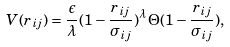Convert formula to latex. <formula><loc_0><loc_0><loc_500><loc_500>V ( r _ { i j } ) = \frac { \epsilon } { \lambda } ( 1 - \frac { r _ { i j } } { \sigma _ { i j } } ) ^ { \lambda } \, \Theta ( 1 - \frac { r _ { i j } } { \sigma _ { i j } } ) ,</formula> 